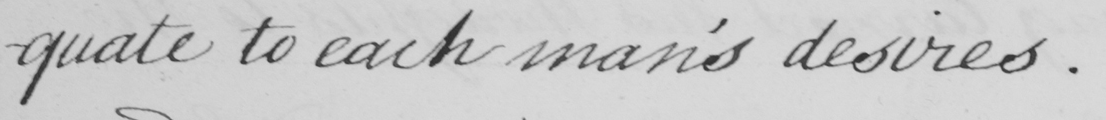Transcribe the text shown in this historical manuscript line. -quate to each man's desires. 